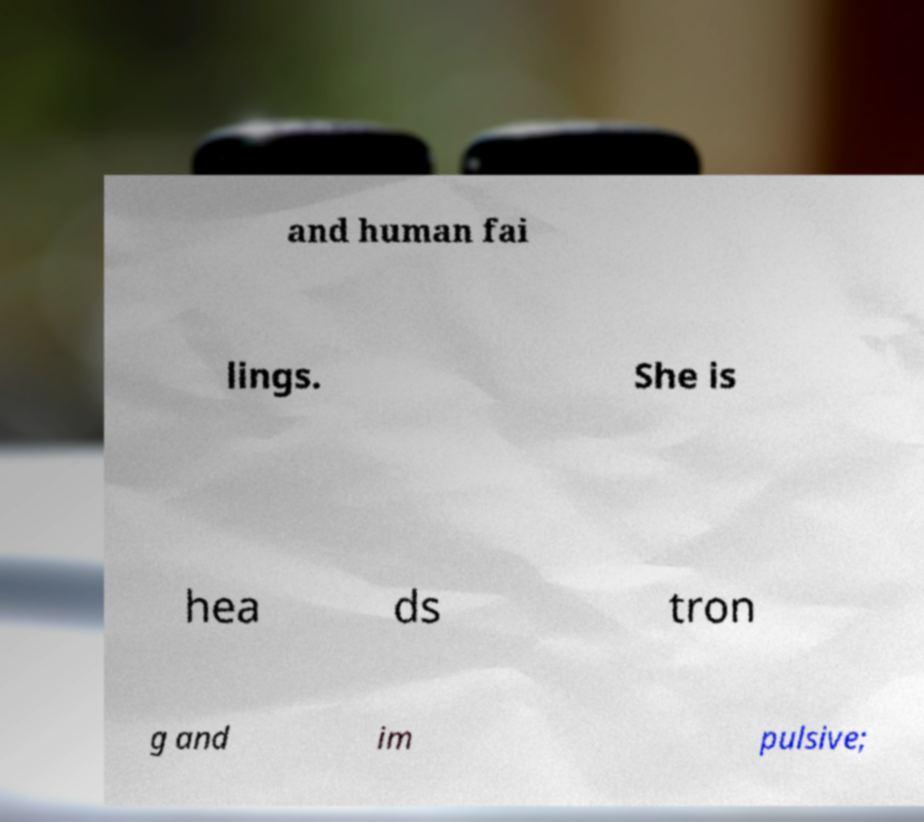Please read and relay the text visible in this image. What does it say? and human fai lings. She is hea ds tron g and im pulsive; 